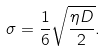<formula> <loc_0><loc_0><loc_500><loc_500>\sigma = \frac { 1 } { 6 } \sqrt { \frac { \eta D } { 2 } } .</formula> 